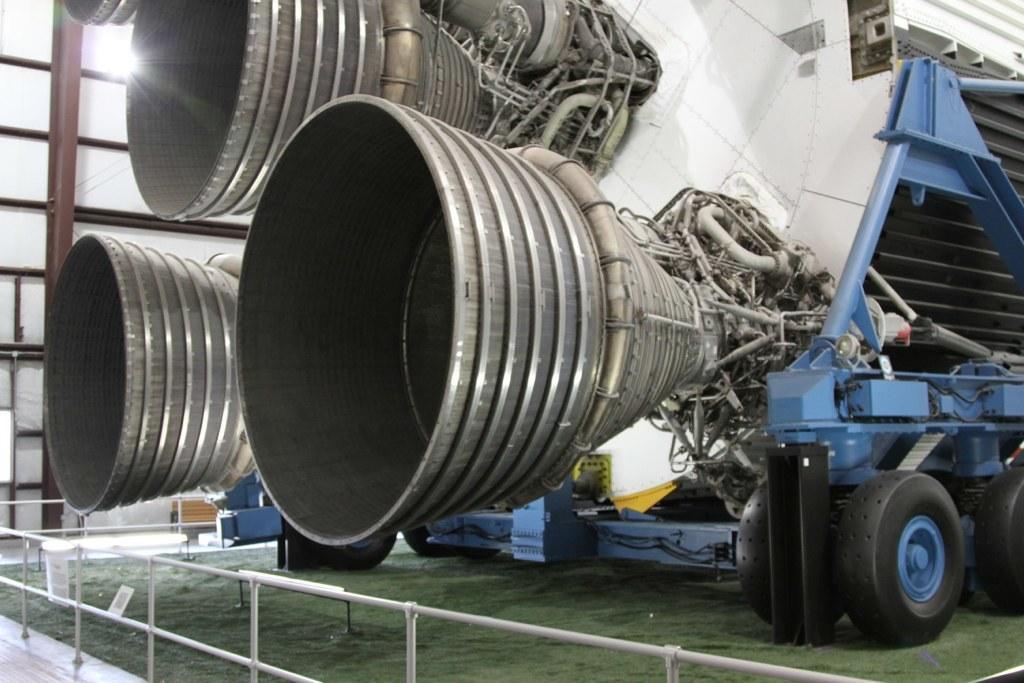Can you describe this image briefly? In this picture we can see a machine attached to the vehicle. These are the tires. And this is the fence. 